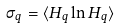<formula> <loc_0><loc_0><loc_500><loc_500>\sigma _ { q } = \langle H _ { q } \ln H _ { q } \rangle</formula> 